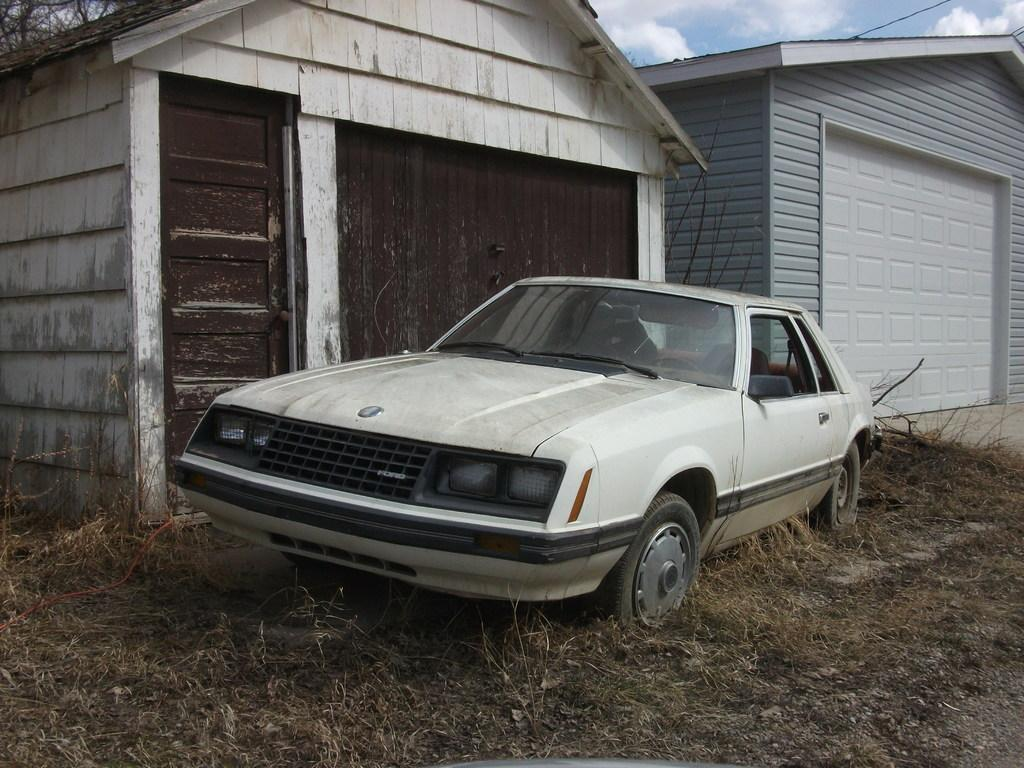What is the main subject on the ground in the image? There is a vehicle on the ground in the image. What can be seen near the vehicle? There are houses beside the vehicle. What is the condition of the sky in the image? The sky is clear in the image. Can you tell me where the queen is sitting in the vehicle? There is no queen present in the image, and therefore no information about her location in the vehicle. 